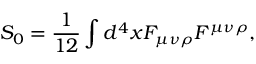Convert formula to latex. <formula><loc_0><loc_0><loc_500><loc_500>S _ { 0 } = { \frac { 1 } { 1 2 } } \int d ^ { 4 } x F _ { \mu \nu \rho } F ^ { \mu \nu \rho } ,</formula> 